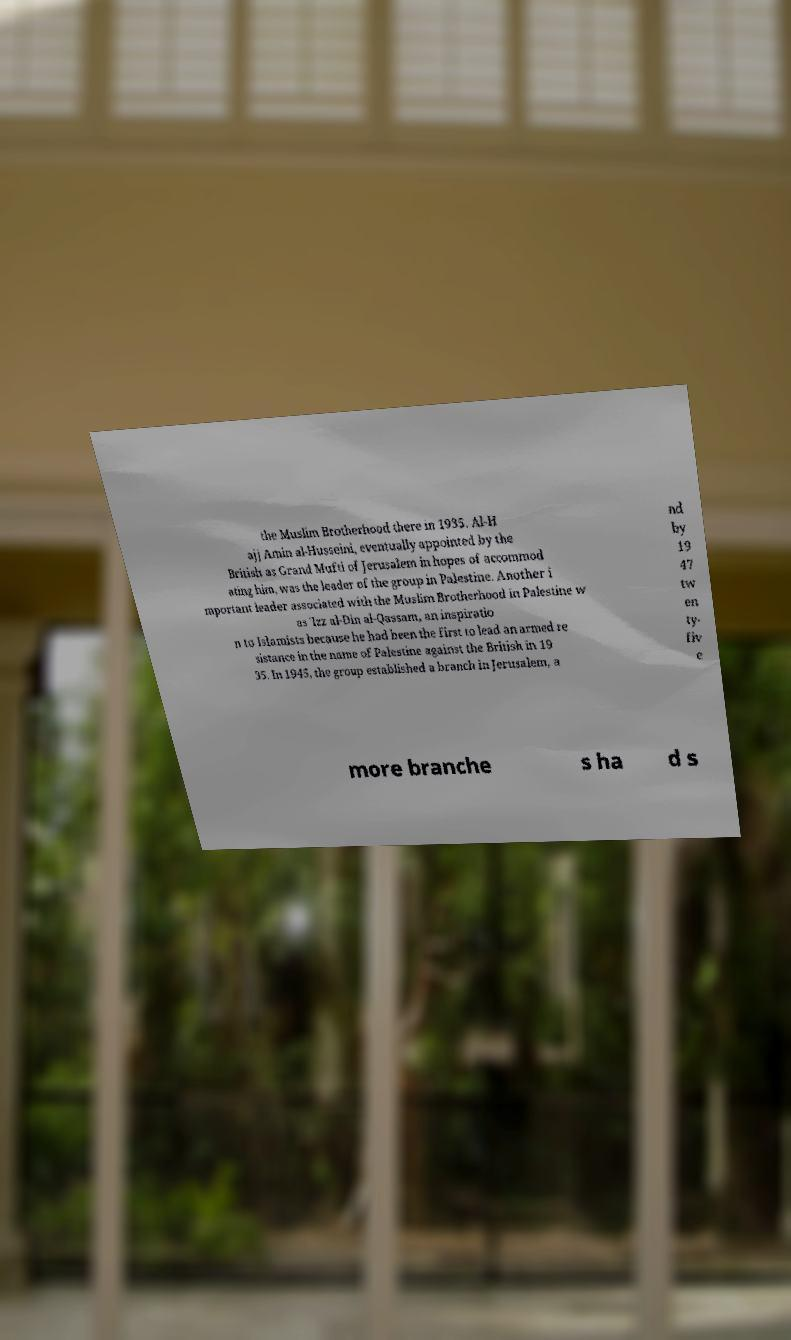I need the written content from this picture converted into text. Can you do that? the Muslim Brotherhood there in 1935. Al-H ajj Amin al-Husseini, eventually appointed by the British as Grand Mufti of Jerusalem in hopes of accommod ating him, was the leader of the group in Palestine. Another i mportant leader associated with the Muslim Brotherhood in Palestine w as 'Izz al-Din al-Qassam, an inspiratio n to Islamists because he had been the first to lead an armed re sistance in the name of Palestine against the British in 19 35. In 1945, the group established a branch in Jerusalem, a nd by 19 47 tw en ty- fiv e more branche s ha d s 